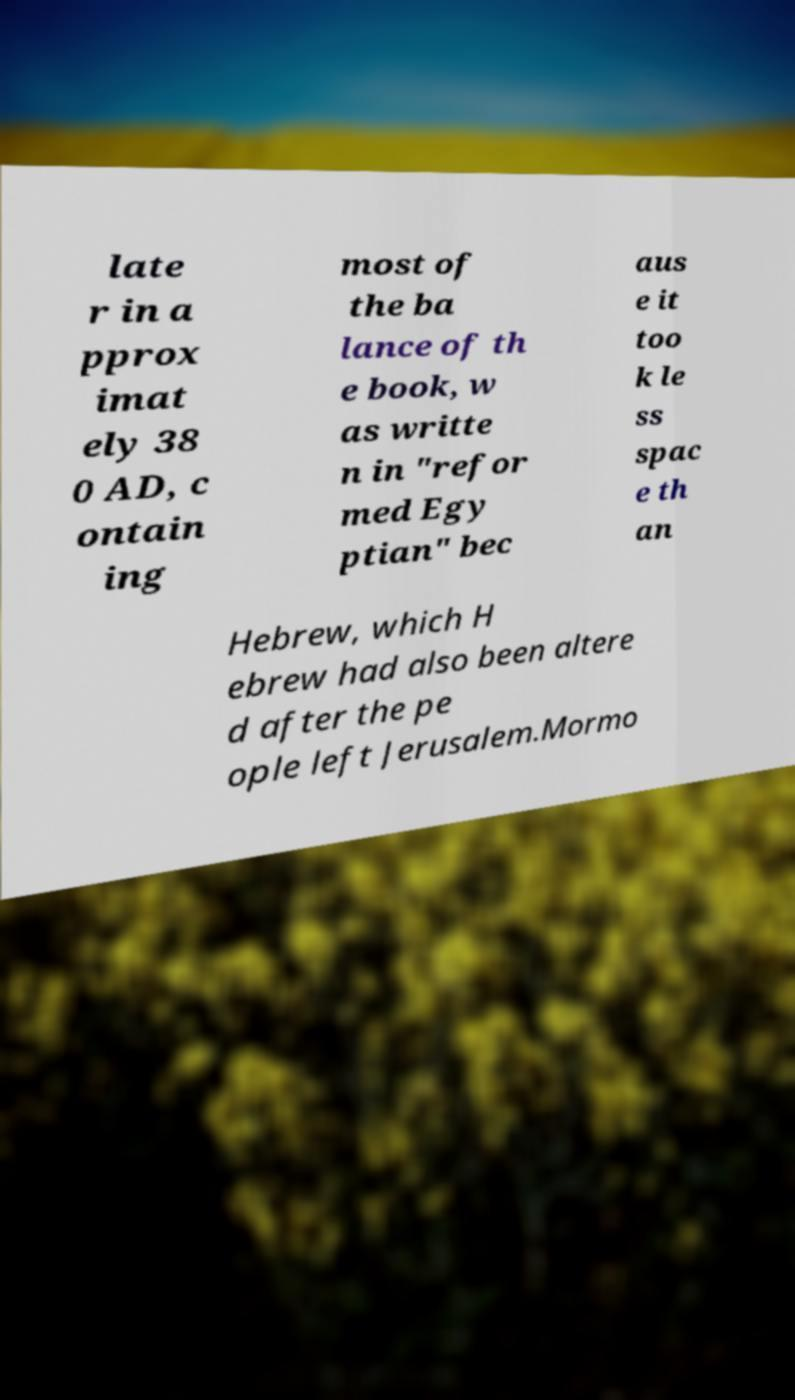Please identify and transcribe the text found in this image. late r in a pprox imat ely 38 0 AD, c ontain ing most of the ba lance of th e book, w as writte n in "refor med Egy ptian" bec aus e it too k le ss spac e th an Hebrew, which H ebrew had also been altere d after the pe ople left Jerusalem.Mormo 